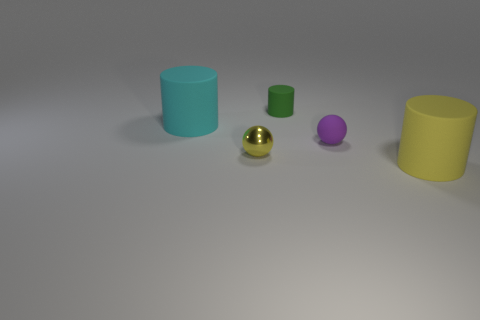Add 1 large shiny cubes. How many objects exist? 6 Subtract all cylinders. How many objects are left? 2 Subtract 0 brown cylinders. How many objects are left? 5 Subtract all tiny shiny spheres. Subtract all tiny purple matte balls. How many objects are left? 3 Add 3 green objects. How many green objects are left? 4 Add 5 small purple shiny spheres. How many small purple shiny spheres exist? 5 